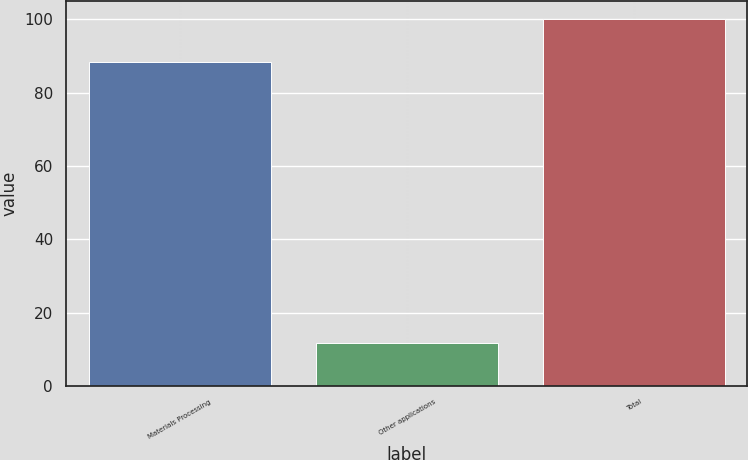Convert chart to OTSL. <chart><loc_0><loc_0><loc_500><loc_500><bar_chart><fcel>Materials Processing<fcel>Other applications<fcel>Total<nl><fcel>88.4<fcel>11.6<fcel>100<nl></chart> 